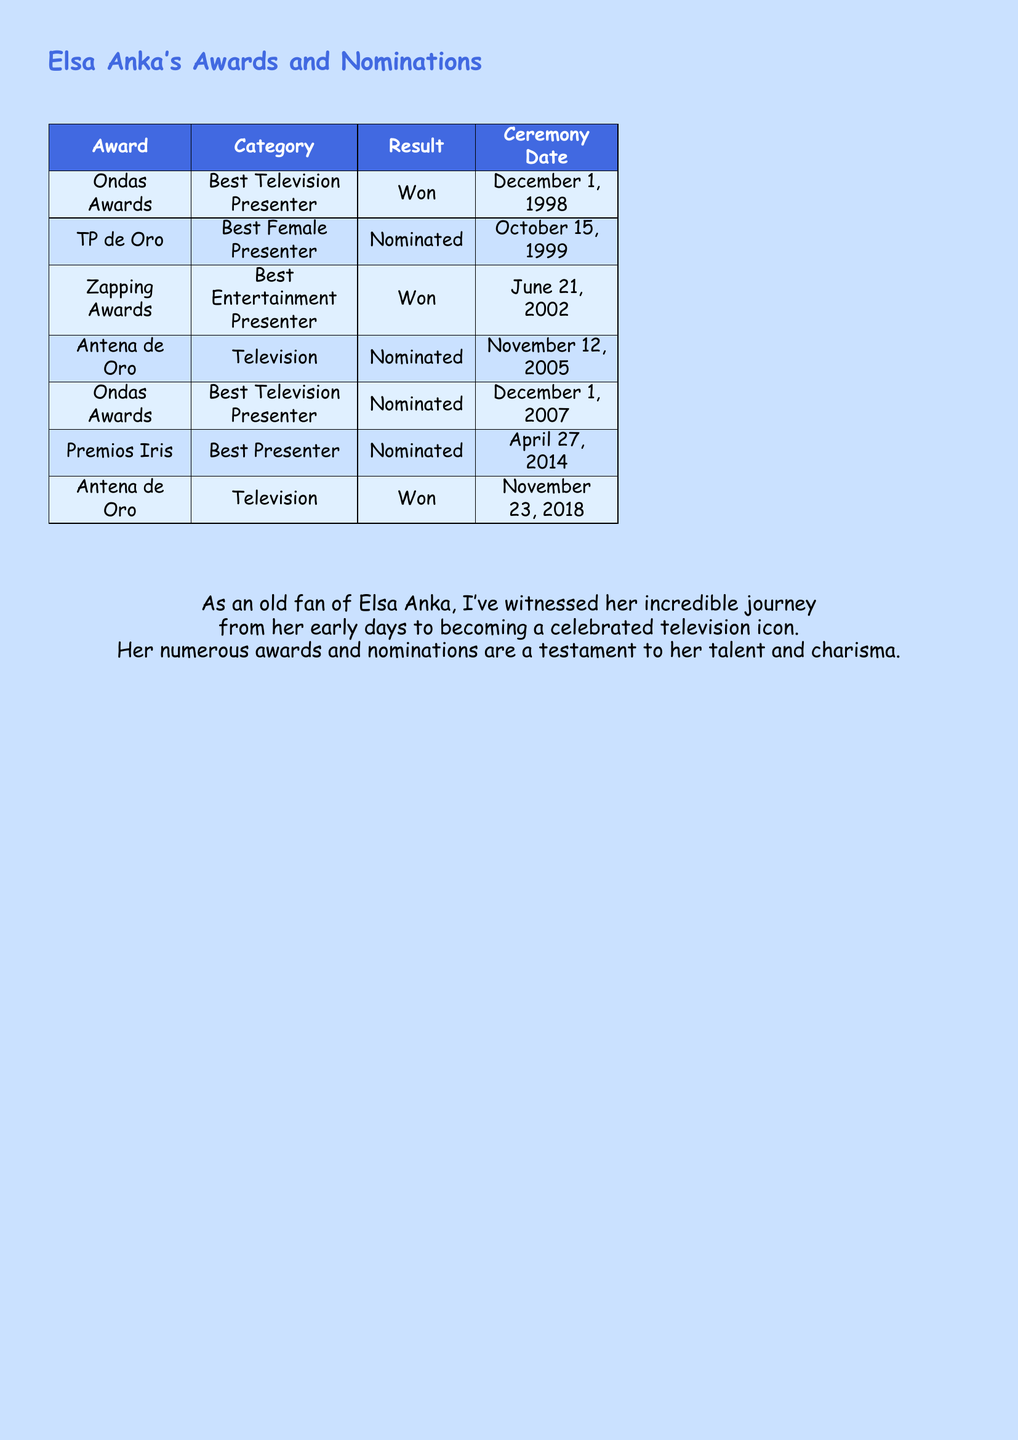What award did Elsa Anka win on December 1, 1998? The award won by Elsa Anka on December 1, 1998, is the Ondas Awards for Best Television Presenter.
Answer: Ondas Awards How many times was Elsa Anka nominated for the TP de Oro? Elsa Anka was nominated for the TP de Oro once, on October 15, 1999.
Answer: 1 Which award did she win on November 23, 2018? The award won by Elsa Anka on November 23, 2018, is the Antena de Oro for Television.
Answer: Antena de Oro In which year did Elsa Anka receive her first award? Elsa Anka received her first award in 1998, during the Ondas Awards.
Answer: 1998 How many total awards has Elsa Anka won according to the document? According to the document, Elsa Anka has won 2 awards: Ondas Awards and Antena de Oro.
Answer: 2 What is the category for which she was nominated at the Premios Iris? At the Premios Iris, she was nominated in the Best Presenter category.
Answer: Best Presenter Which ceremony date is associated with the Zapping Awards? The Zapping Awards ceremony date associated with Elsa Anka is June 21, 2002.
Answer: June 21, 2002 How many nominations does the document list for Elsa Anka? The document lists a total of 4 nominations for Elsa Anka.
Answer: 4 